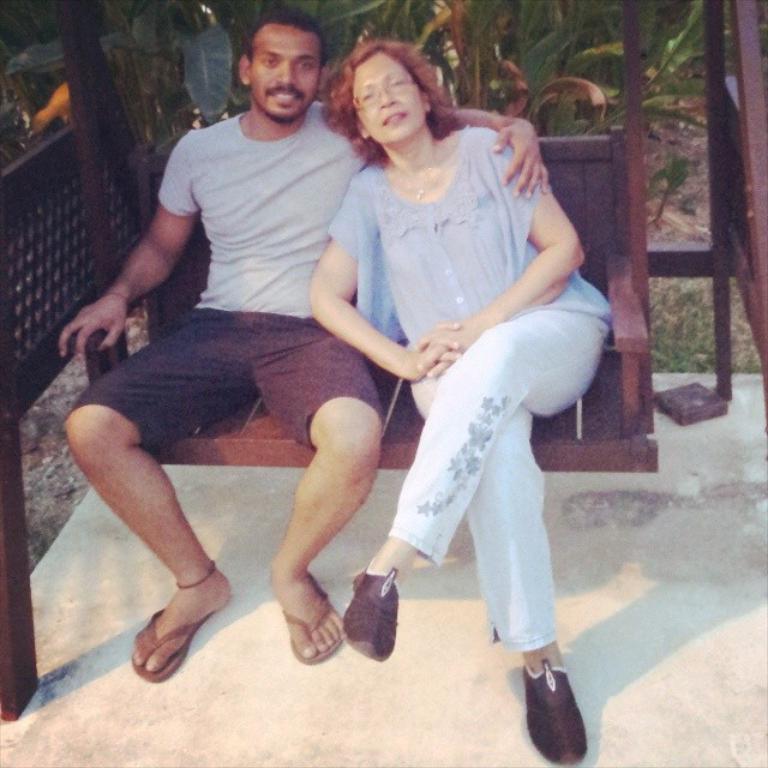Can you describe this image briefly? In the center of the image we can see two persons are sitting on the swing. In the background, we can see the grass and plants. 